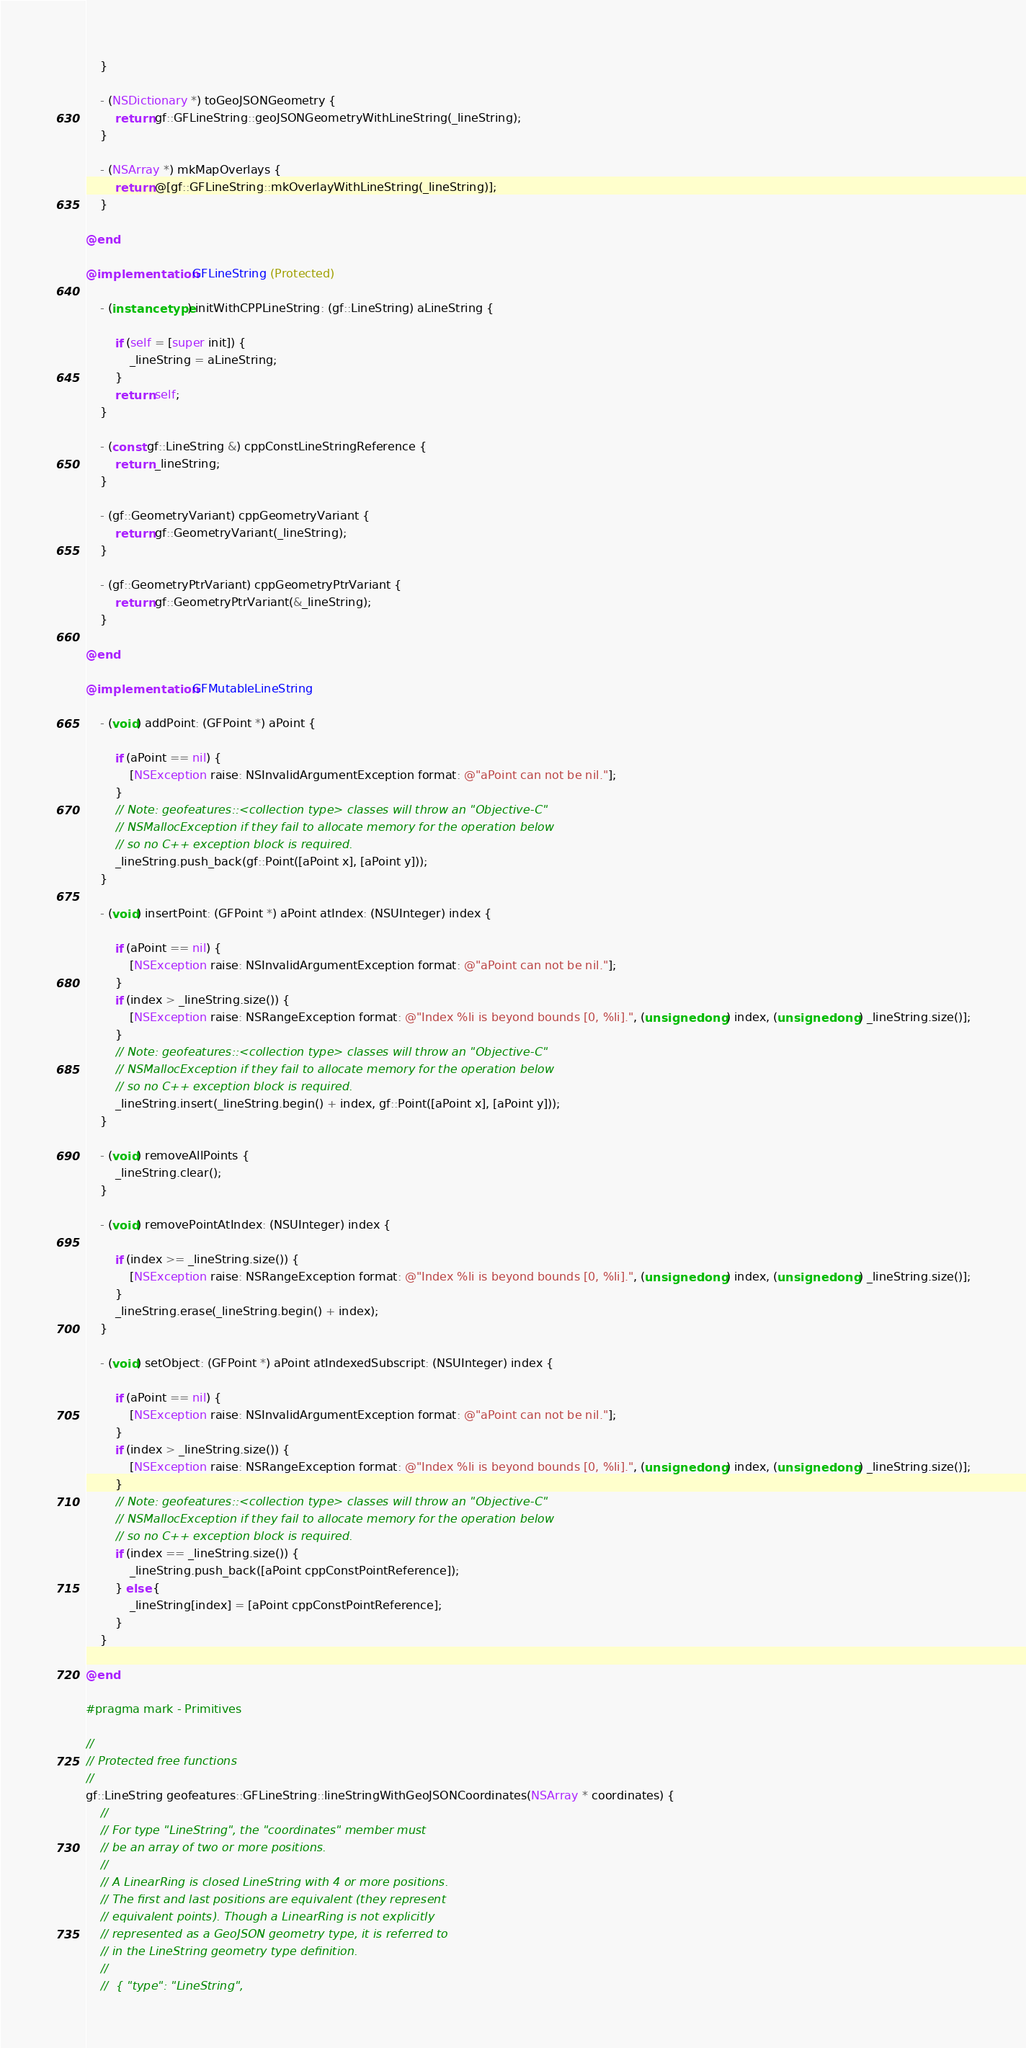Convert code to text. <code><loc_0><loc_0><loc_500><loc_500><_ObjectiveC_>    }

    - (NSDictionary *) toGeoJSONGeometry {
        return gf::GFLineString::geoJSONGeometryWithLineString(_lineString);
    }

    - (NSArray *) mkMapOverlays {
        return @[gf::GFLineString::mkOverlayWithLineString(_lineString)];
    }

@end

@implementation GFLineString (Protected)

    - (instancetype) initWithCPPLineString: (gf::LineString) aLineString {

        if (self = [super init]) {
            _lineString = aLineString;
        }
        return self;
    }

    - (const gf::LineString &) cppConstLineStringReference {
        return _lineString;
    }

    - (gf::GeometryVariant) cppGeometryVariant {
        return gf::GeometryVariant(_lineString);
    }

    - (gf::GeometryPtrVariant) cppGeometryPtrVariant {
        return gf::GeometryPtrVariant(&_lineString);
    }

@end

@implementation GFMutableLineString

    - (void) addPoint: (GFPoint *) aPoint {

        if (aPoint == nil) {
            [NSException raise: NSInvalidArgumentException format: @"aPoint can not be nil."];
        }
        // Note: geofeatures::<collection type> classes will throw an "Objective-C"
        // NSMallocException if they fail to allocate memory for the operation below
        // so no C++ exception block is required.
        _lineString.push_back(gf::Point([aPoint x], [aPoint y]));
    }

    - (void) insertPoint: (GFPoint *) aPoint atIndex: (NSUInteger) index {

        if (aPoint == nil) {
            [NSException raise: NSInvalidArgumentException format: @"aPoint can not be nil."];
        }
        if (index > _lineString.size()) {
            [NSException raise: NSRangeException format: @"Index %li is beyond bounds [0, %li].", (unsigned long) index, (unsigned long) _lineString.size()];
        }
        // Note: geofeatures::<collection type> classes will throw an "Objective-C"
        // NSMallocException if they fail to allocate memory for the operation below
        // so no C++ exception block is required.
        _lineString.insert(_lineString.begin() + index, gf::Point([aPoint x], [aPoint y]));
    }

    - (void) removeAllPoints {
        _lineString.clear();
    }

    - (void) removePointAtIndex: (NSUInteger) index {

        if (index >= _lineString.size()) {
            [NSException raise: NSRangeException format: @"Index %li is beyond bounds [0, %li].", (unsigned long) index, (unsigned long) _lineString.size()];
        }
        _lineString.erase(_lineString.begin() + index);
    }

    - (void) setObject: (GFPoint *) aPoint atIndexedSubscript: (NSUInteger) index {

        if (aPoint == nil) {
            [NSException raise: NSInvalidArgumentException format: @"aPoint can not be nil."];
        }
        if (index > _lineString.size()) {
            [NSException raise: NSRangeException format: @"Index %li is beyond bounds [0, %li].", (unsigned long) index, (unsigned long) _lineString.size()];
        }
        // Note: geofeatures::<collection type> classes will throw an "Objective-C"
        // NSMallocException if they fail to allocate memory for the operation below
        // so no C++ exception block is required.
        if (index == _lineString.size()) {
            _lineString.push_back([aPoint cppConstPointReference]);
        } else {
            _lineString[index] = [aPoint cppConstPointReference];
        }
    }

@end

#pragma mark - Primitives

//
// Protected free functions
//
gf::LineString geofeatures::GFLineString::lineStringWithGeoJSONCoordinates(NSArray * coordinates) {
    //
    // For type "LineString", the "coordinates" member must
    // be an array of two or more positions.
    //
    // A LinearRing is closed LineString with 4 or more positions.
    // The first and last positions are equivalent (they represent
    // equivalent points). Though a LinearRing is not explicitly
    // represented as a GeoJSON geometry type, it is referred to
    // in the LineString geometry type definition.
    //
    //  { "type": "LineString",</code> 